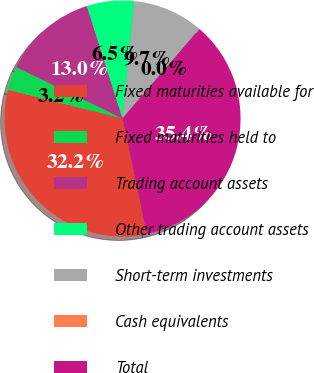<chart> <loc_0><loc_0><loc_500><loc_500><pie_chart><fcel>Fixed maturities available for<fcel>Fixed maturities held to<fcel>Trading account assets<fcel>Other trading account assets<fcel>Short-term investments<fcel>Cash equivalents<fcel>Total<nl><fcel>32.19%<fcel>3.24%<fcel>12.95%<fcel>6.48%<fcel>9.71%<fcel>0.0%<fcel>35.42%<nl></chart> 